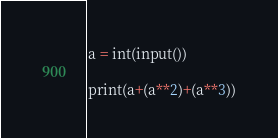Convert code to text. <code><loc_0><loc_0><loc_500><loc_500><_Python_>a = int(input())

print(a+(a**2)+(a**3))</code> 